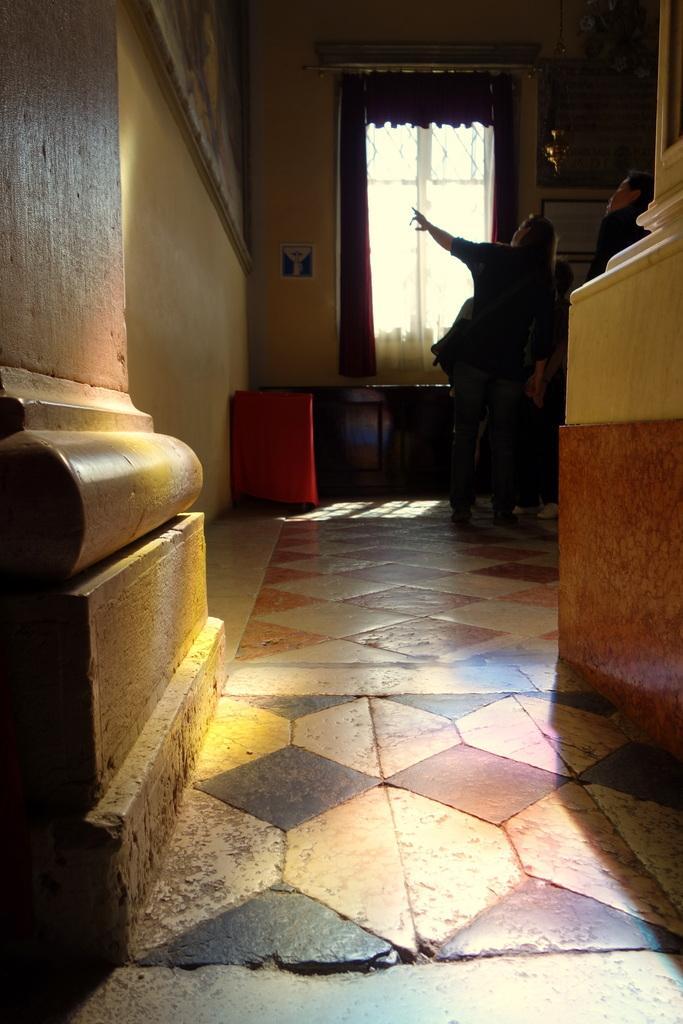Can you describe this image briefly? In this image it looks like a frame on the wall in the left corner. There are people and there are objects on the wall in the right corner. There is floor at the bottom. There is a window, curtain, there are objects, there is a wall in the background. 